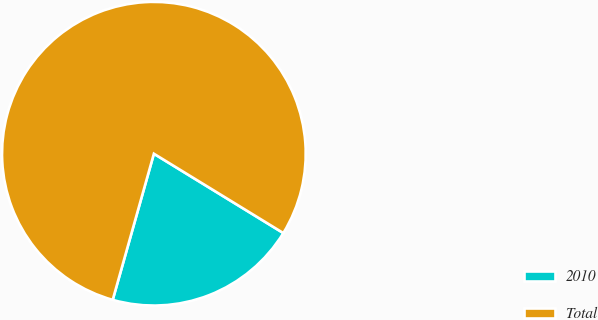Convert chart to OTSL. <chart><loc_0><loc_0><loc_500><loc_500><pie_chart><fcel>2010<fcel>Total<nl><fcel>20.62%<fcel>79.38%<nl></chart> 